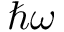Convert formula to latex. <formula><loc_0><loc_0><loc_500><loc_500>\hbar { \omega }</formula> 